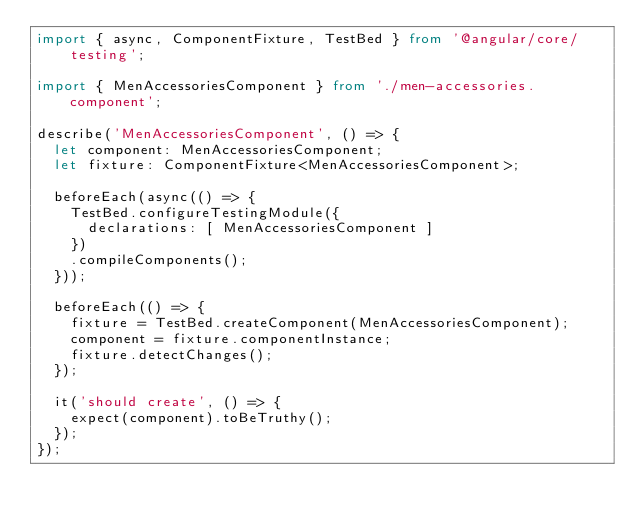<code> <loc_0><loc_0><loc_500><loc_500><_TypeScript_>import { async, ComponentFixture, TestBed } from '@angular/core/testing';

import { MenAccessoriesComponent } from './men-accessories.component';

describe('MenAccessoriesComponent', () => {
  let component: MenAccessoriesComponent;
  let fixture: ComponentFixture<MenAccessoriesComponent>;

  beforeEach(async(() => {
    TestBed.configureTestingModule({
      declarations: [ MenAccessoriesComponent ]
    })
    .compileComponents();
  }));

  beforeEach(() => {
    fixture = TestBed.createComponent(MenAccessoriesComponent);
    component = fixture.componentInstance;
    fixture.detectChanges();
  });

  it('should create', () => {
    expect(component).toBeTruthy();
  });
});
</code> 